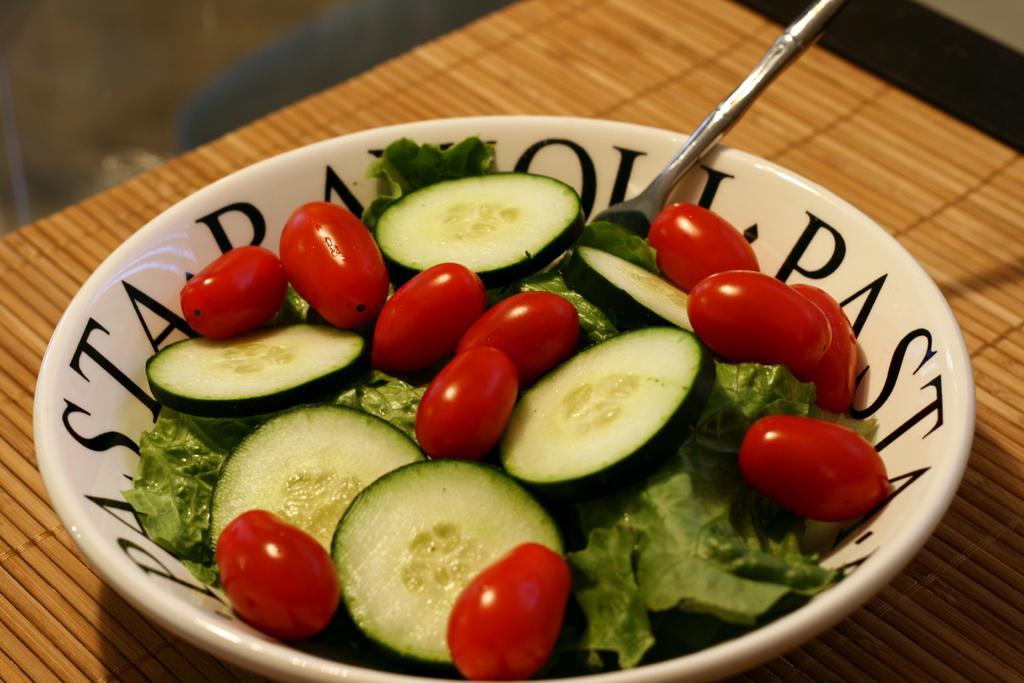Please provide a concise description of this image. This image consists of a bowl. In which we can see the slices of cucumber and cherries along with a spoon. At the bottom, there is a table. And we can see a table mat. 